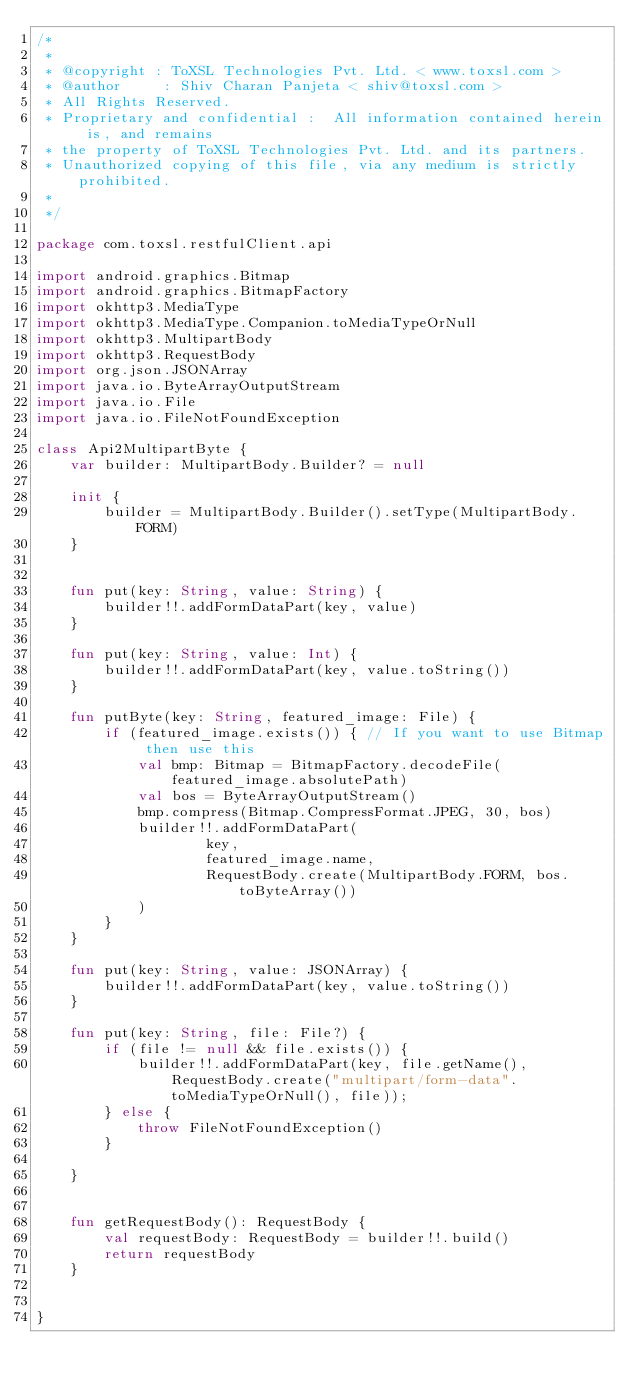<code> <loc_0><loc_0><loc_500><loc_500><_Kotlin_>/*
 *
 * @copyright : ToXSL Technologies Pvt. Ltd. < www.toxsl.com >
 * @author     : Shiv Charan Panjeta < shiv@toxsl.com >
 * All Rights Reserved.
 * Proprietary and confidential :  All information contained herein is, and remains
 * the property of ToXSL Technologies Pvt. Ltd. and its partners.
 * Unauthorized copying of this file, via any medium is strictly prohibited.
 *  
 */

package com.toxsl.restfulClient.api

import android.graphics.Bitmap
import android.graphics.BitmapFactory
import okhttp3.MediaType
import okhttp3.MediaType.Companion.toMediaTypeOrNull
import okhttp3.MultipartBody
import okhttp3.RequestBody
import org.json.JSONArray
import java.io.ByteArrayOutputStream
import java.io.File
import java.io.FileNotFoundException

class Api2MultipartByte {
    var builder: MultipartBody.Builder? = null

    init {
        builder = MultipartBody.Builder().setType(MultipartBody.FORM)
    }


    fun put(key: String, value: String) {
        builder!!.addFormDataPart(key, value)
    }

    fun put(key: String, value: Int) {
        builder!!.addFormDataPart(key, value.toString())
    }

    fun putByte(key: String, featured_image: File) {
        if (featured_image.exists()) { // If you want to use Bitmap then use this
            val bmp: Bitmap = BitmapFactory.decodeFile(featured_image.absolutePath)
            val bos = ByteArrayOutputStream()
            bmp.compress(Bitmap.CompressFormat.JPEG, 30, bos)
            builder!!.addFormDataPart(
                    key,
                    featured_image.name,
                    RequestBody.create(MultipartBody.FORM, bos.toByteArray())
            )
        }
    }

    fun put(key: String, value: JSONArray) {
        builder!!.addFormDataPart(key, value.toString())
    }

    fun put(key: String, file: File?) {
        if (file != null && file.exists()) {
            builder!!.addFormDataPart(key, file.getName(), RequestBody.create("multipart/form-data".toMediaTypeOrNull(), file));
        } else {
            throw FileNotFoundException()
        }

    }


    fun getRequestBody(): RequestBody {
        val requestBody: RequestBody = builder!!.build()
        return requestBody
    }


}</code> 